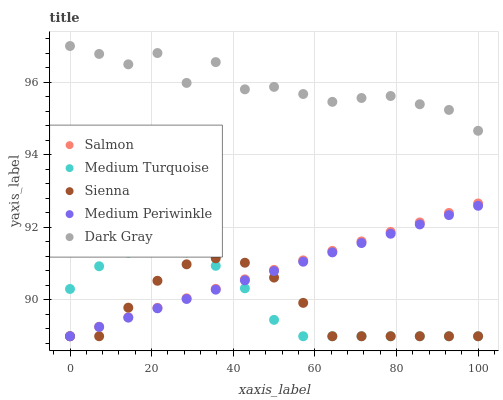Does Sienna have the minimum area under the curve?
Answer yes or no. Yes. Does Dark Gray have the maximum area under the curve?
Answer yes or no. Yes. Does Medium Periwinkle have the minimum area under the curve?
Answer yes or no. No. Does Medium Periwinkle have the maximum area under the curve?
Answer yes or no. No. Is Salmon the smoothest?
Answer yes or no. Yes. Is Dark Gray the roughest?
Answer yes or no. Yes. Is Medium Periwinkle the smoothest?
Answer yes or no. No. Is Medium Periwinkle the roughest?
Answer yes or no. No. Does Sienna have the lowest value?
Answer yes or no. Yes. Does Dark Gray have the lowest value?
Answer yes or no. No. Does Dark Gray have the highest value?
Answer yes or no. Yes. Does Medium Periwinkle have the highest value?
Answer yes or no. No. Is Sienna less than Dark Gray?
Answer yes or no. Yes. Is Dark Gray greater than Medium Turquoise?
Answer yes or no. Yes. Does Medium Turquoise intersect Medium Periwinkle?
Answer yes or no. Yes. Is Medium Turquoise less than Medium Periwinkle?
Answer yes or no. No. Is Medium Turquoise greater than Medium Periwinkle?
Answer yes or no. No. Does Sienna intersect Dark Gray?
Answer yes or no. No. 